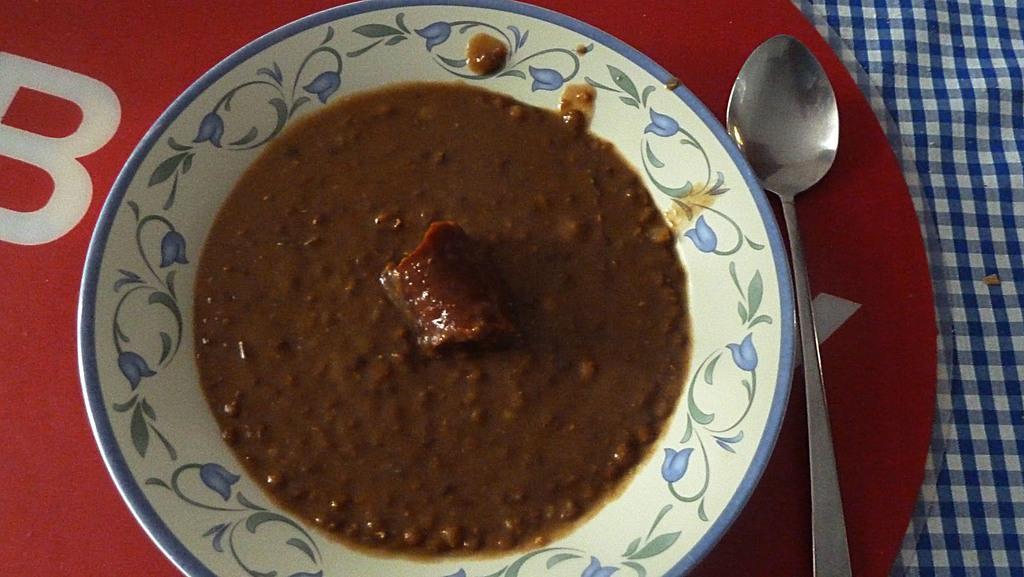Could you give a brief overview of what you see in this image? In this image in the center there is a plate, and in the plate there is some food and beside the plate there is one spoon and under the plate there is one plastic object and cloth. 